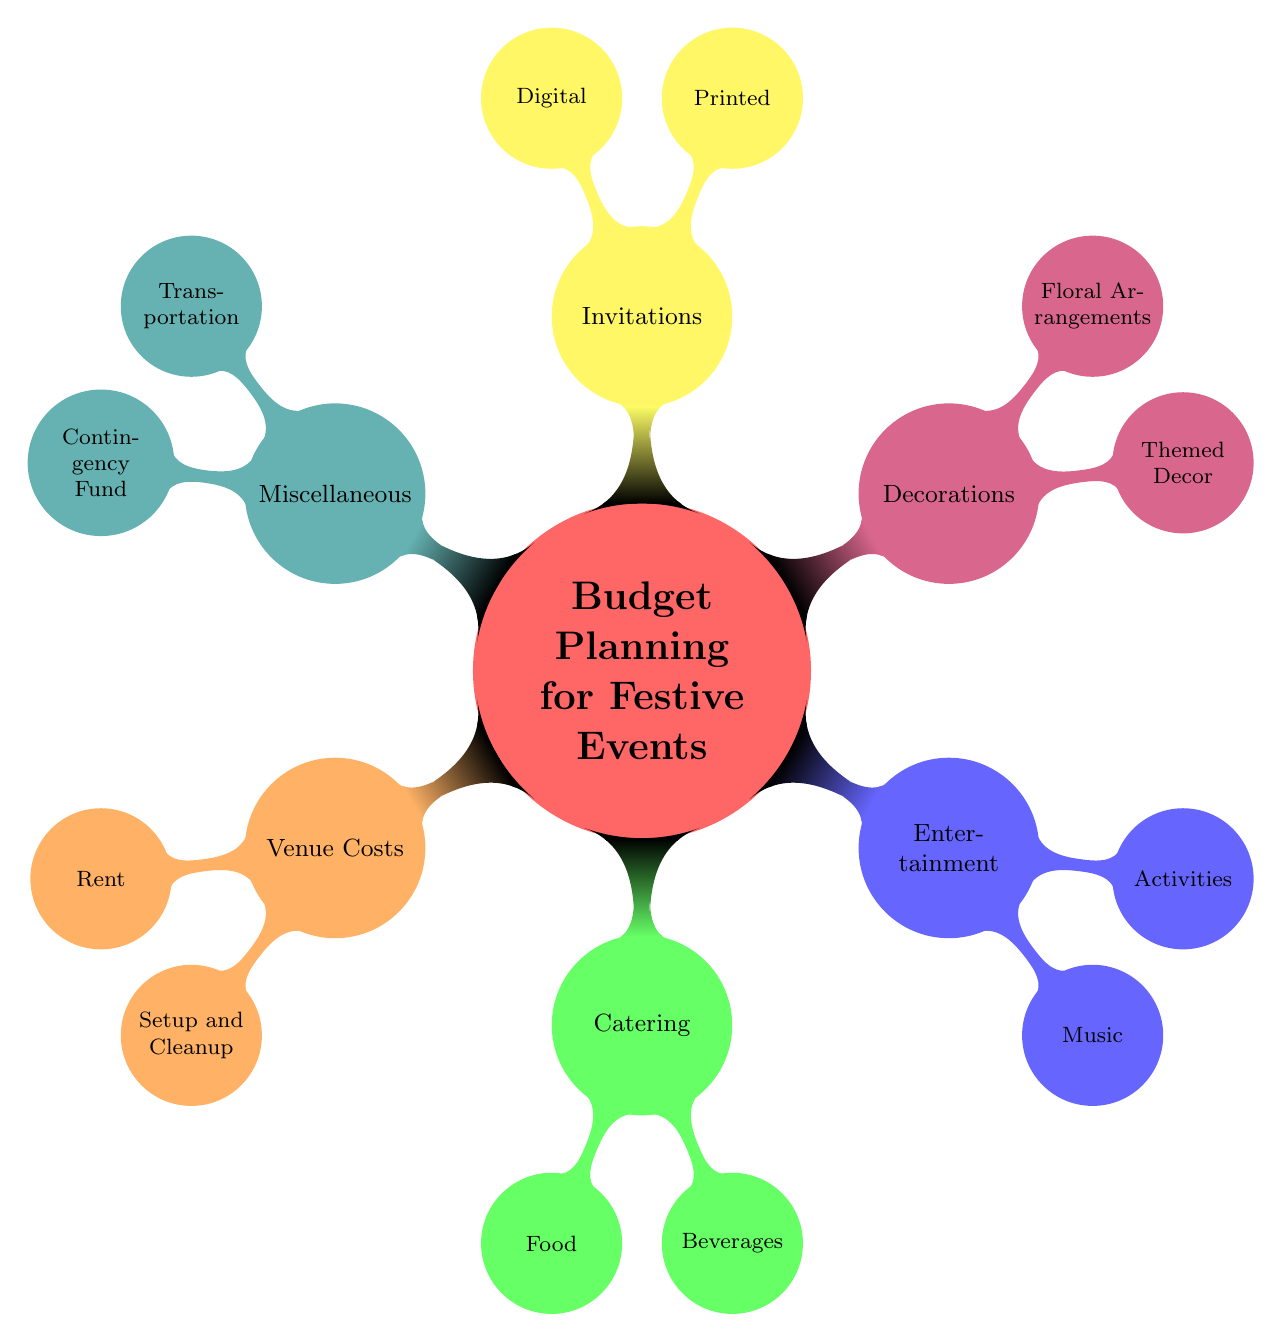What are the two main categories under Venue Costs? The diagram shows that "Venue Costs" has two main subcategories: "Rent" and "Setup and Cleanup." These are directly connected beneath the "Venue Costs" node.
Answer: Rent, Setup and Cleanup How many options are listed under Catering? The "Catering" node has two suboptions displayed: "Food" and "Beverages." This means there are a total of two options under the "Catering" category.
Answer: 2 Which entertainment option is specifically mentioned for music? The diagram indicates that the "Music" category under "Entertainment" features two choices: "Live Band" and "DJ." The question is about the specific options listed.
Answer: Live Band or DJ What is the relationship between Decorations and Invitations? The diagram illustrates that both "Decorations" and "Invitations" are equally categorized under the main node "Budget Planning for Festive Events." They are siblings in the hierarchy of nodes.
Answer: Siblings What type of transportation is mentioned under Miscellaneous? Under the "Miscellaneous" category, the diagram portrays "Transportation" as one of its subcategories, specifically mentioning "Shuttle Services or Car Rentals." This identifies the transportation options available.
Answer: Shuttle Services or Car Rentals How many main categories are there in the Mind Map? The Mind Map displays six main categories branching out from the central "Budget Planning for Festive Events" node: Venue Costs, Catering, Entertainment, Decorations, Invitations, and Miscellaneous.
Answer: 6 What is the contingency fund used for? The diagram specifies that the "Contingency Fund" under the "Miscellaneous" category is intended for "Emergency or Unexpected Expenses." This highlights its purpose within the event planning context.
Answer: Emergency or Unexpected Expenses Which subcategory under Decorations suggests custom themes? The "Themed Decor" subcategory under "Decorations" mentions "Seasonal Decorations or Custom Themes," indicating the type of decor that can be customized for festive events.
Answer: Custom Themes 